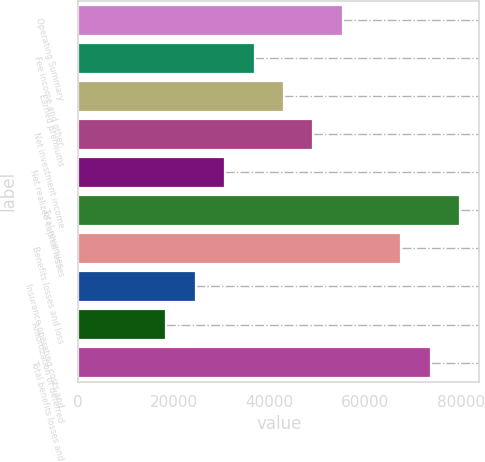<chart> <loc_0><loc_0><loc_500><loc_500><bar_chart><fcel>Operating Summary<fcel>Fee income and other<fcel>Earned premiums<fcel>Net investment income<fcel>Net realized capital losses<fcel>Total revenues<fcel>Benefits losses and loss<fcel>Insurance operating costs and<fcel>Amortization of deferred<fcel>Total benefits losses and<nl><fcel>55329.2<fcel>36888.8<fcel>43035.6<fcel>49182.4<fcel>30742<fcel>79916.4<fcel>67622.8<fcel>24595.2<fcel>18448.4<fcel>73769.6<nl></chart> 